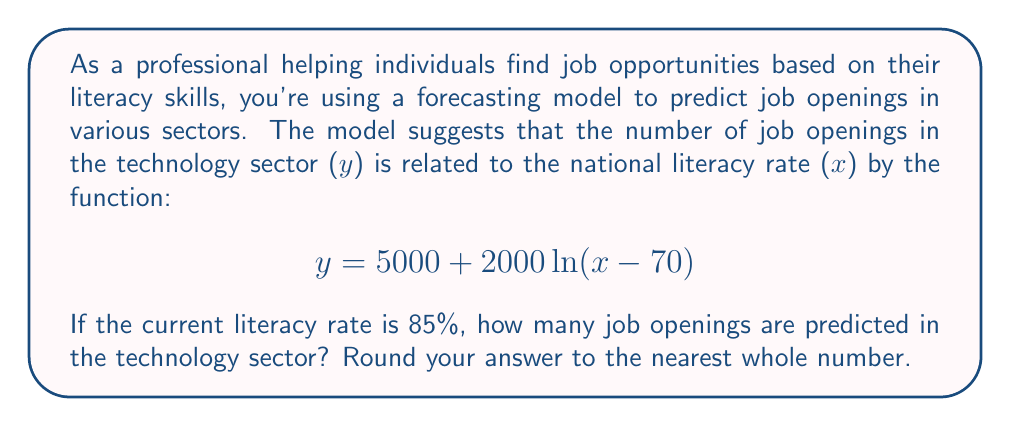Provide a solution to this math problem. To solve this problem, we need to follow these steps:

1. Identify the given information:
   - The function is $y = 5000 + 2000\ln(x - 70)$
   - $x$ represents the literacy rate
   - $y$ represents the number of job openings in the technology sector
   - The current literacy rate is 85%

2. Substitute the given literacy rate into the function:
   $x = 85$

3. Calculate $y$ by plugging in the value of $x$:
   $$\begin{align}
   y &= 5000 + 2000\ln(85 - 70) \\
   &= 5000 + 2000\ln(15)
   \end{align}$$

4. Evaluate the natural logarithm:
   $\ln(15) \approx 2.70805$

5. Complete the calculation:
   $$\begin{align}
   y &= 5000 + 2000(2.70805) \\
   &= 5000 + 5416.1 \\
   &= 10416.1
   \end{align}$$

6. Round the result to the nearest whole number:
   $y \approx 10416$

Therefore, the model predicts approximately 10,416 job openings in the technology sector when the literacy rate is 85%.
Answer: 10,416 job openings 